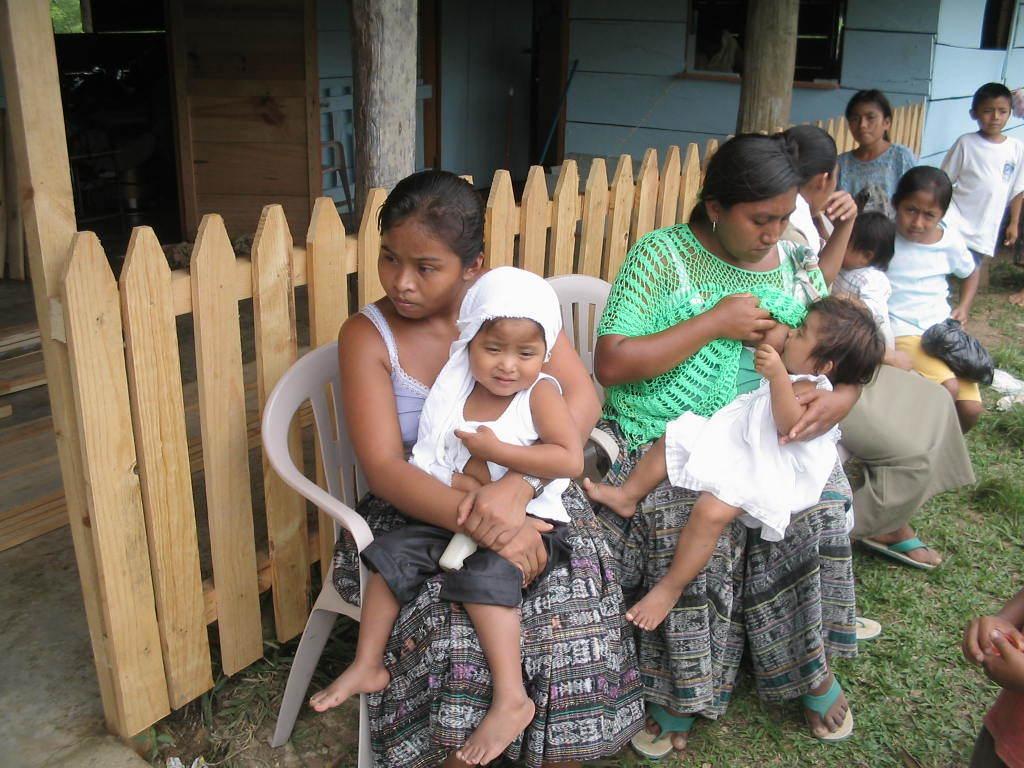Can you describe this image briefly? In this image we can see a girl is holding a small boy in the hands and she is sitting on a chair and beside them a woman is breastfeeding a kid by sitting on a chair. In the background we can see few persons, house, fence, windows, objects and a door. 